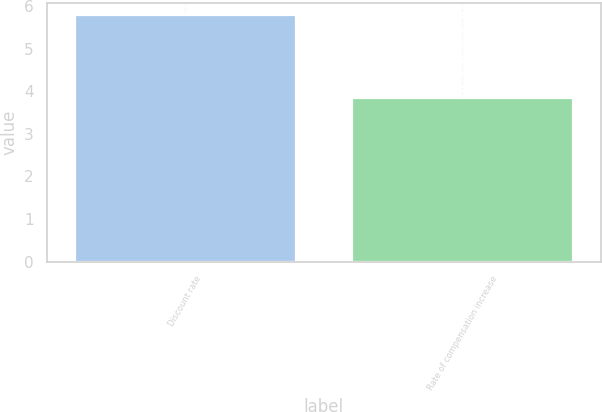<chart> <loc_0><loc_0><loc_500><loc_500><bar_chart><fcel>Discount rate<fcel>Rate of compensation increase<nl><fcel>5.79<fcel>3.84<nl></chart> 